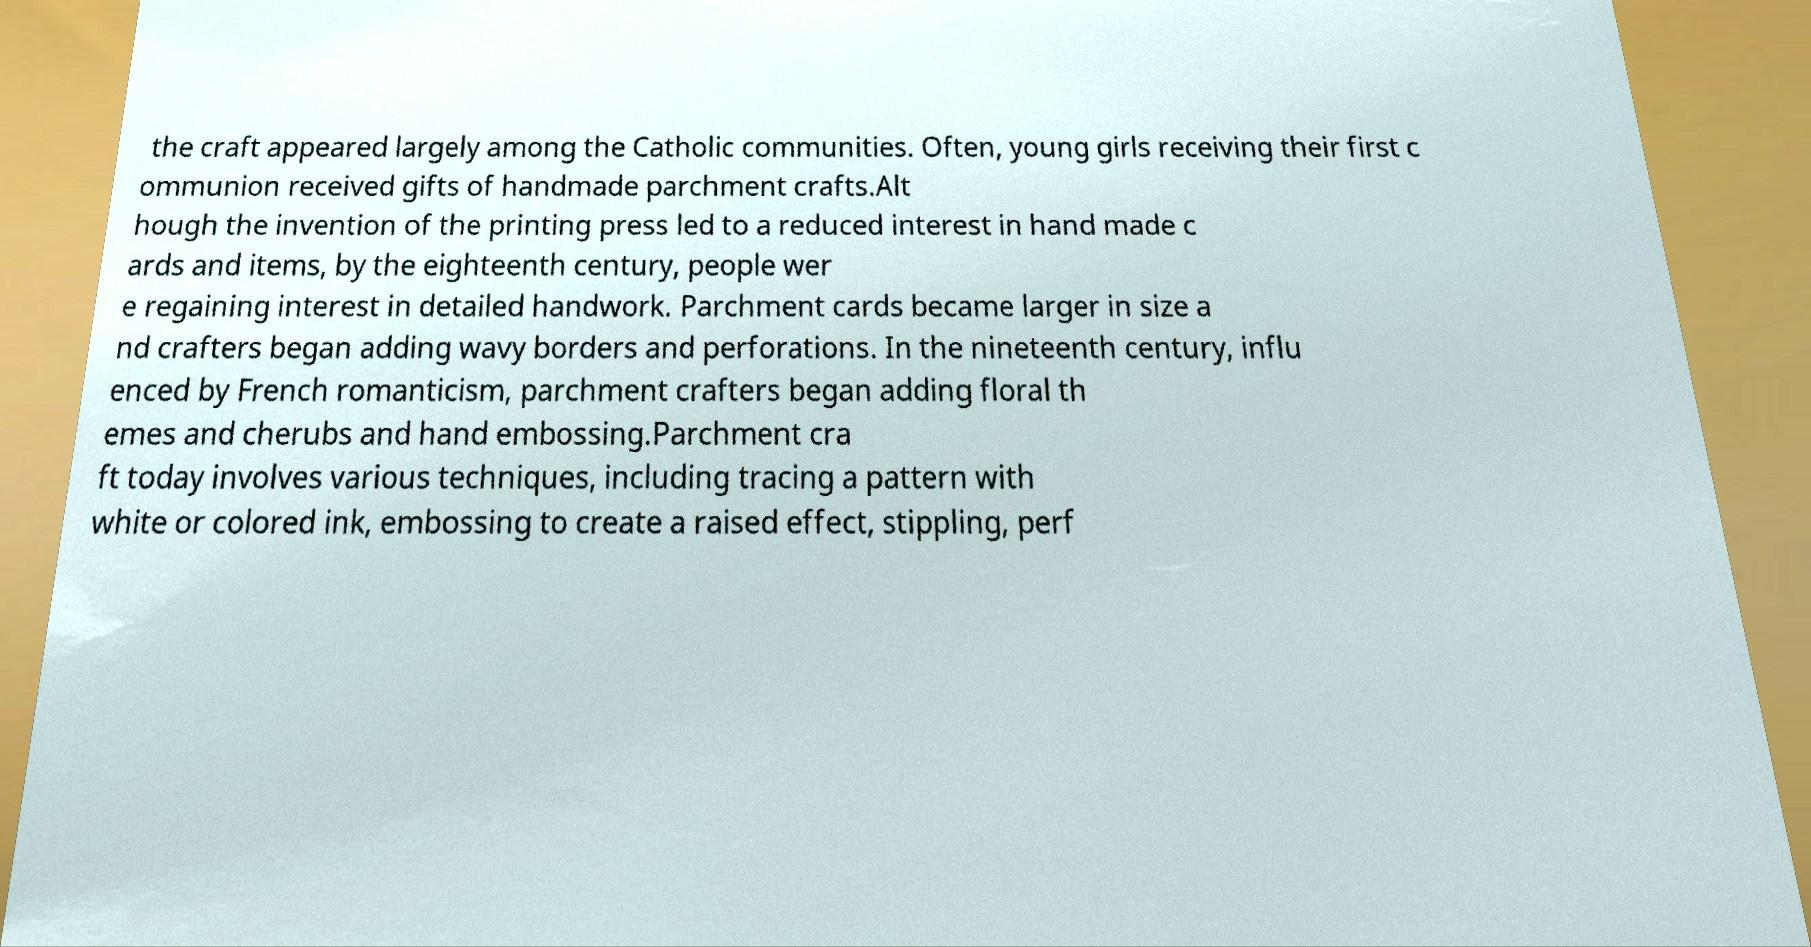I need the written content from this picture converted into text. Can you do that? the craft appeared largely among the Catholic communities. Often, young girls receiving their first c ommunion received gifts of handmade parchment crafts.Alt hough the invention of the printing press led to a reduced interest in hand made c ards and items, by the eighteenth century, people wer e regaining interest in detailed handwork. Parchment cards became larger in size a nd crafters began adding wavy borders and perforations. In the nineteenth century, influ enced by French romanticism, parchment crafters began adding floral th emes and cherubs and hand embossing.Parchment cra ft today involves various techniques, including tracing a pattern with white or colored ink, embossing to create a raised effect, stippling, perf 